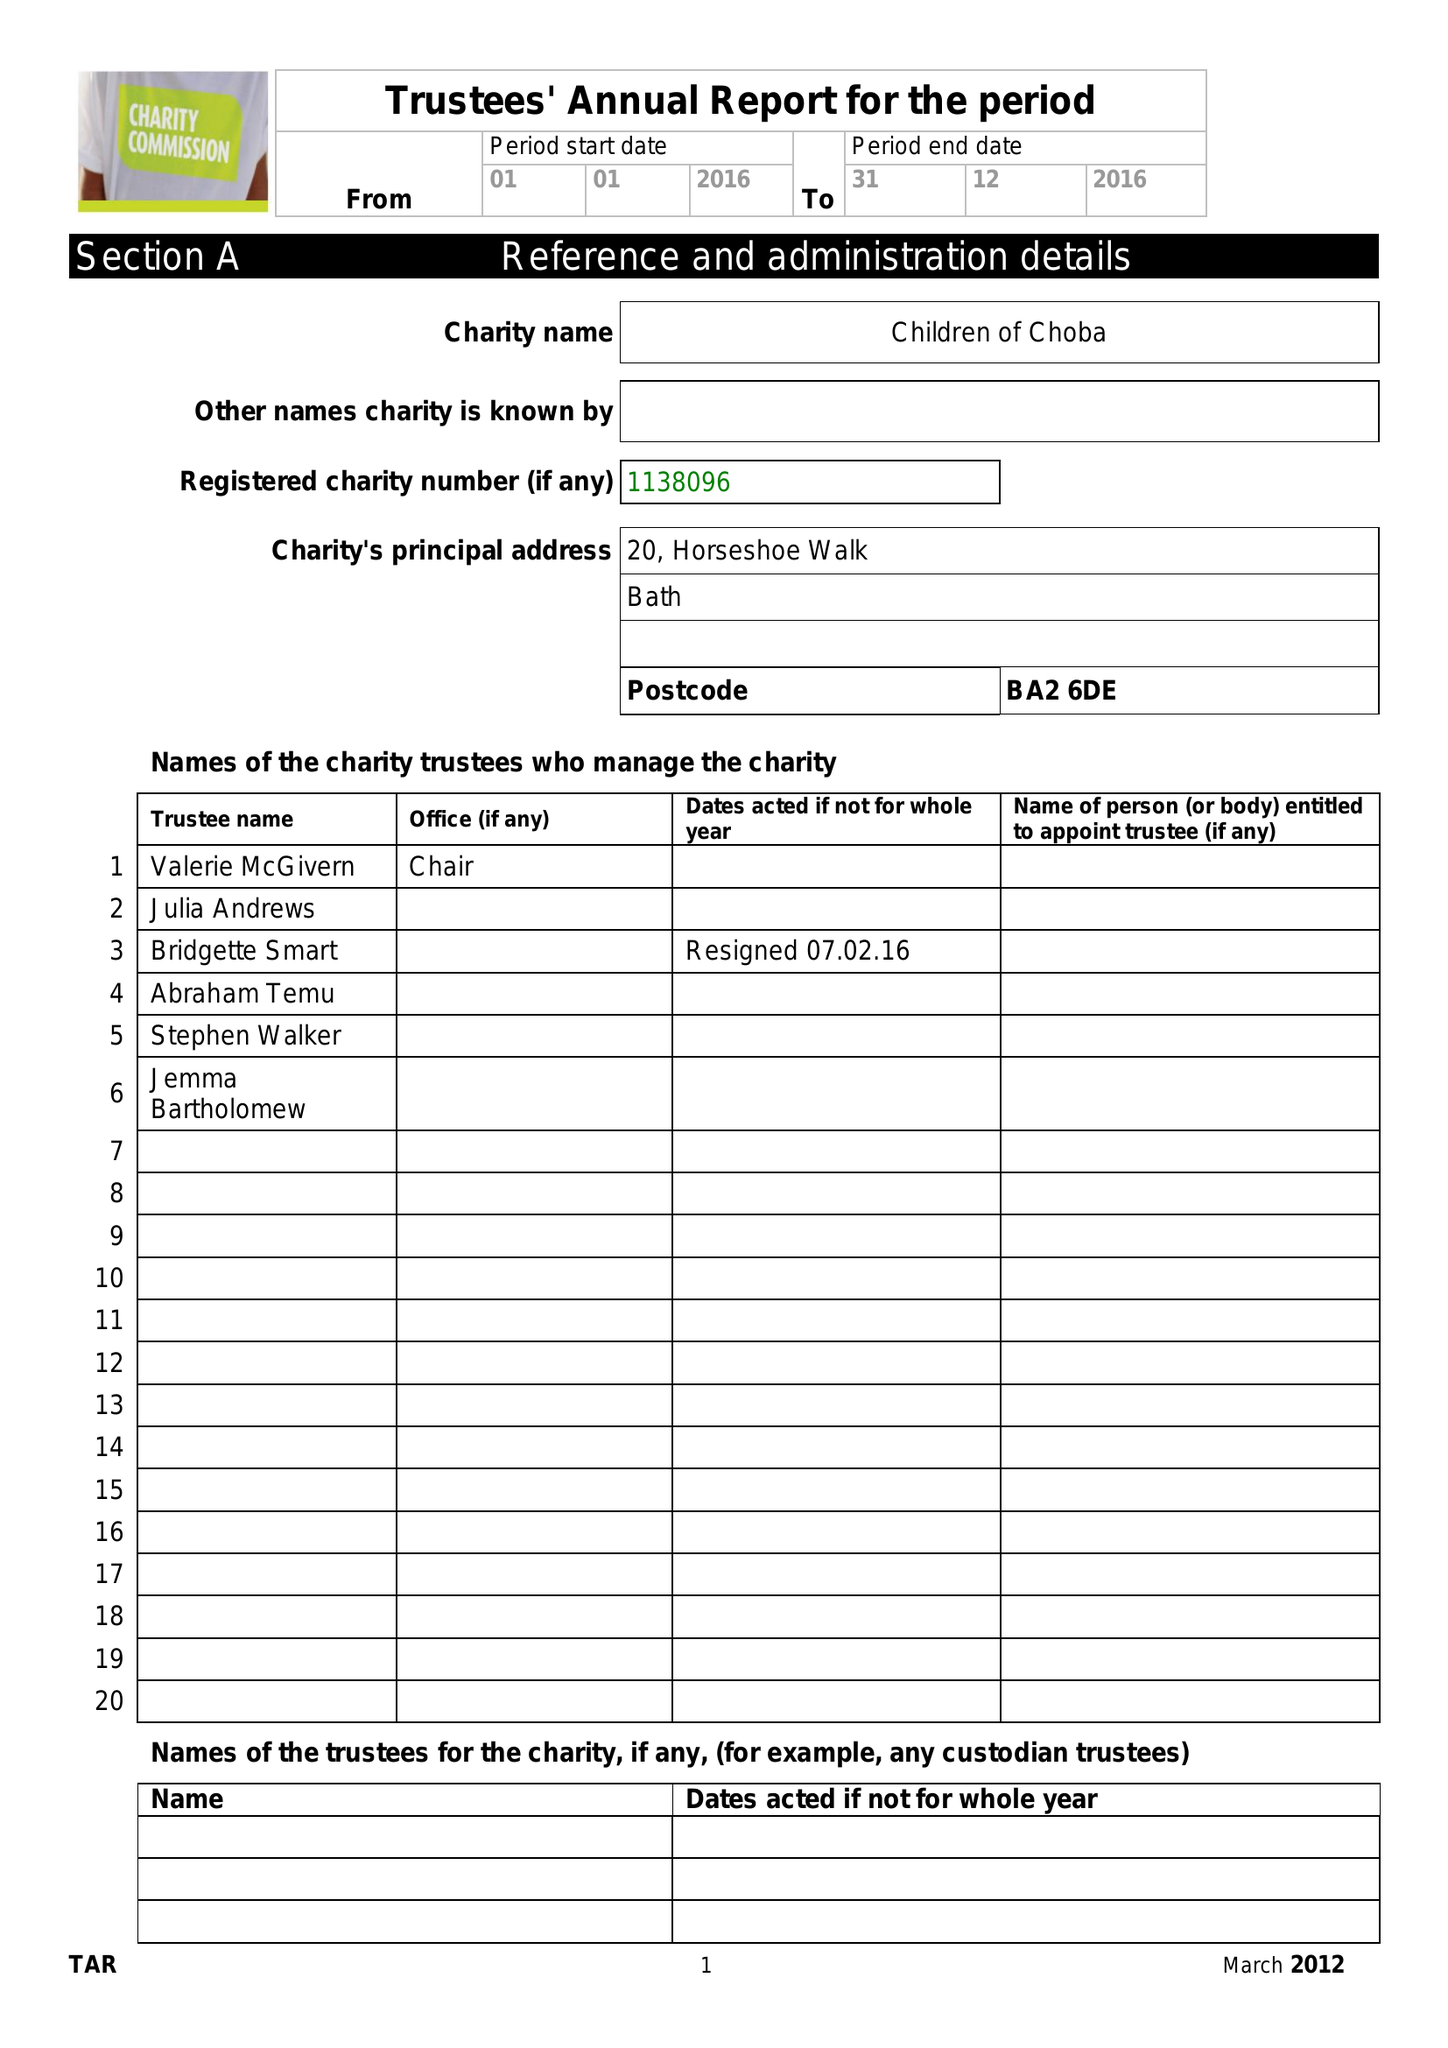What is the value for the charity_name?
Answer the question using a single word or phrase. Children Of Choba 